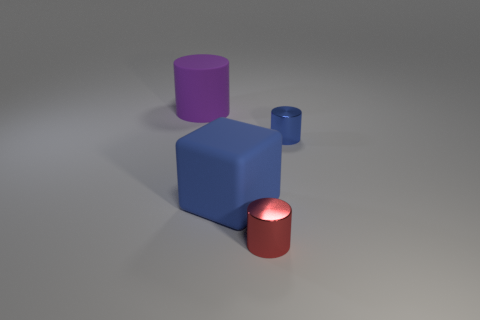There is a red metal object; how many purple rubber cylinders are to the left of it?
Make the answer very short. 1. Is there a blue metal thing of the same size as the red cylinder?
Make the answer very short. Yes. The large rubber object that is the same shape as the red shiny thing is what color?
Your response must be concise. Purple. Is the size of the metal thing that is in front of the big cube the same as the rubber object in front of the blue cylinder?
Keep it short and to the point. No. Are there any blue objects that have the same shape as the red shiny object?
Make the answer very short. Yes. Is the number of large blocks that are to the right of the tiny blue metal thing the same as the number of purple rubber cylinders?
Offer a very short reply. No. There is a red metal cylinder; is its size the same as the shiny cylinder that is behind the red metallic cylinder?
Offer a terse response. Yes. What number of other tiny red cylinders are made of the same material as the tiny red cylinder?
Your response must be concise. 0. Does the red shiny thing have the same size as the rubber cylinder?
Give a very brief answer. No. Are there any other things that are the same color as the matte block?
Provide a succinct answer. Yes. 